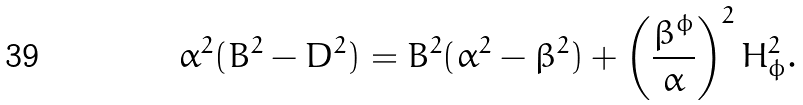<formula> <loc_0><loc_0><loc_500><loc_500>\alpha ^ { 2 } ( B ^ { 2 } - D ^ { 2 } ) = B ^ { 2 } ( \alpha ^ { 2 } - \beta ^ { 2 } ) + \left ( \frac { \beta ^ { \phi } } { \alpha } \right ) ^ { 2 } H _ { \phi } ^ { 2 } .</formula> 